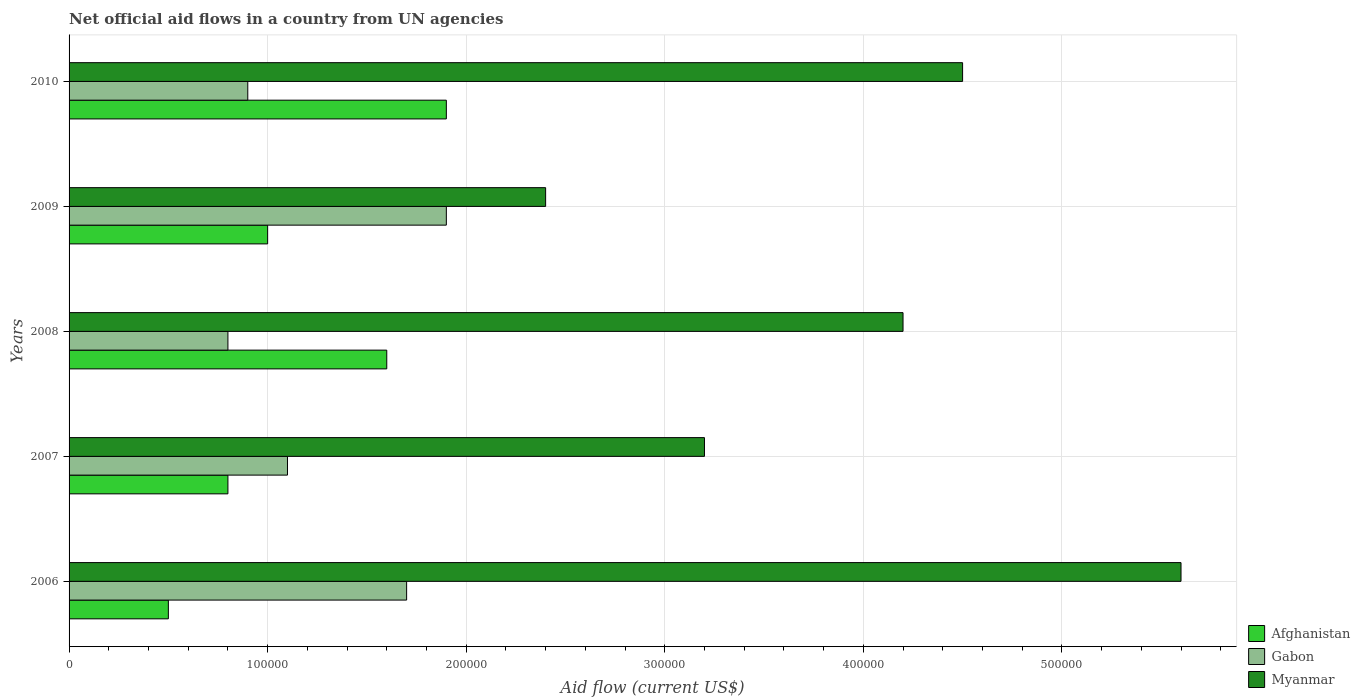How many groups of bars are there?
Offer a terse response. 5. Are the number of bars on each tick of the Y-axis equal?
Provide a short and direct response. Yes. In how many cases, is the number of bars for a given year not equal to the number of legend labels?
Your answer should be very brief. 0. What is the net official aid flow in Afghanistan in 2008?
Your answer should be compact. 1.60e+05. Across all years, what is the maximum net official aid flow in Myanmar?
Ensure brevity in your answer.  5.60e+05. Across all years, what is the minimum net official aid flow in Afghanistan?
Provide a succinct answer. 5.00e+04. In which year was the net official aid flow in Gabon maximum?
Give a very brief answer. 2009. What is the total net official aid flow in Gabon in the graph?
Provide a succinct answer. 6.40e+05. What is the difference between the net official aid flow in Gabon in 2006 and that in 2009?
Your answer should be compact. -2.00e+04. What is the difference between the net official aid flow in Myanmar in 2006 and the net official aid flow in Gabon in 2009?
Your answer should be very brief. 3.70e+05. What is the average net official aid flow in Gabon per year?
Your answer should be very brief. 1.28e+05. In the year 2006, what is the difference between the net official aid flow in Myanmar and net official aid flow in Gabon?
Your answer should be compact. 3.90e+05. What is the ratio of the net official aid flow in Gabon in 2006 to that in 2008?
Give a very brief answer. 2.12. Is the net official aid flow in Myanmar in 2009 less than that in 2010?
Your answer should be very brief. Yes. What is the difference between the highest and the second highest net official aid flow in Afghanistan?
Ensure brevity in your answer.  3.00e+04. What is the difference between the highest and the lowest net official aid flow in Gabon?
Ensure brevity in your answer.  1.10e+05. What does the 2nd bar from the top in 2009 represents?
Your answer should be compact. Gabon. What does the 3rd bar from the bottom in 2008 represents?
Give a very brief answer. Myanmar. Is it the case that in every year, the sum of the net official aid flow in Gabon and net official aid flow in Afghanistan is greater than the net official aid flow in Myanmar?
Offer a terse response. No. Are all the bars in the graph horizontal?
Make the answer very short. Yes. How many years are there in the graph?
Your answer should be very brief. 5. Does the graph contain grids?
Give a very brief answer. Yes. Where does the legend appear in the graph?
Make the answer very short. Bottom right. How many legend labels are there?
Your answer should be very brief. 3. What is the title of the graph?
Ensure brevity in your answer.  Net official aid flows in a country from UN agencies. What is the label or title of the X-axis?
Provide a short and direct response. Aid flow (current US$). What is the label or title of the Y-axis?
Your response must be concise. Years. What is the Aid flow (current US$) in Gabon in 2006?
Make the answer very short. 1.70e+05. What is the Aid flow (current US$) of Myanmar in 2006?
Offer a very short reply. 5.60e+05. What is the Aid flow (current US$) in Afghanistan in 2007?
Your answer should be very brief. 8.00e+04. What is the Aid flow (current US$) in Gabon in 2007?
Provide a short and direct response. 1.10e+05. What is the Aid flow (current US$) in Afghanistan in 2008?
Your response must be concise. 1.60e+05. What is the Aid flow (current US$) of Gabon in 2008?
Provide a short and direct response. 8.00e+04. What is the Aid flow (current US$) in Myanmar in 2008?
Keep it short and to the point. 4.20e+05. What is the Aid flow (current US$) in Gabon in 2009?
Your response must be concise. 1.90e+05. What is the Aid flow (current US$) of Myanmar in 2009?
Provide a succinct answer. 2.40e+05. What is the Aid flow (current US$) of Afghanistan in 2010?
Your response must be concise. 1.90e+05. What is the Aid flow (current US$) in Gabon in 2010?
Give a very brief answer. 9.00e+04. What is the Aid flow (current US$) of Myanmar in 2010?
Your answer should be compact. 4.50e+05. Across all years, what is the maximum Aid flow (current US$) in Afghanistan?
Your response must be concise. 1.90e+05. Across all years, what is the maximum Aid flow (current US$) of Gabon?
Your answer should be very brief. 1.90e+05. Across all years, what is the maximum Aid flow (current US$) of Myanmar?
Your response must be concise. 5.60e+05. Across all years, what is the minimum Aid flow (current US$) of Gabon?
Offer a very short reply. 8.00e+04. Across all years, what is the minimum Aid flow (current US$) of Myanmar?
Your answer should be very brief. 2.40e+05. What is the total Aid flow (current US$) in Afghanistan in the graph?
Offer a very short reply. 5.80e+05. What is the total Aid flow (current US$) of Gabon in the graph?
Make the answer very short. 6.40e+05. What is the total Aid flow (current US$) of Myanmar in the graph?
Offer a very short reply. 1.99e+06. What is the difference between the Aid flow (current US$) in Afghanistan in 2006 and that in 2007?
Your answer should be very brief. -3.00e+04. What is the difference between the Aid flow (current US$) of Afghanistan in 2006 and that in 2008?
Provide a short and direct response. -1.10e+05. What is the difference between the Aid flow (current US$) in Gabon in 2006 and that in 2009?
Ensure brevity in your answer.  -2.00e+04. What is the difference between the Aid flow (current US$) in Myanmar in 2006 and that in 2009?
Ensure brevity in your answer.  3.20e+05. What is the difference between the Aid flow (current US$) of Afghanistan in 2007 and that in 2008?
Give a very brief answer. -8.00e+04. What is the difference between the Aid flow (current US$) in Gabon in 2007 and that in 2008?
Give a very brief answer. 3.00e+04. What is the difference between the Aid flow (current US$) in Myanmar in 2007 and that in 2008?
Your answer should be compact. -1.00e+05. What is the difference between the Aid flow (current US$) of Afghanistan in 2007 and that in 2009?
Your answer should be very brief. -2.00e+04. What is the difference between the Aid flow (current US$) of Myanmar in 2007 and that in 2009?
Your response must be concise. 8.00e+04. What is the difference between the Aid flow (current US$) in Afghanistan in 2007 and that in 2010?
Make the answer very short. -1.10e+05. What is the difference between the Aid flow (current US$) in Gabon in 2007 and that in 2010?
Offer a very short reply. 2.00e+04. What is the difference between the Aid flow (current US$) in Myanmar in 2007 and that in 2010?
Give a very brief answer. -1.30e+05. What is the difference between the Aid flow (current US$) in Gabon in 2008 and that in 2009?
Provide a short and direct response. -1.10e+05. What is the difference between the Aid flow (current US$) of Gabon in 2008 and that in 2010?
Your answer should be very brief. -10000. What is the difference between the Aid flow (current US$) in Afghanistan in 2009 and that in 2010?
Your answer should be very brief. -9.00e+04. What is the difference between the Aid flow (current US$) of Gabon in 2009 and that in 2010?
Provide a succinct answer. 1.00e+05. What is the difference between the Aid flow (current US$) of Myanmar in 2009 and that in 2010?
Offer a very short reply. -2.10e+05. What is the difference between the Aid flow (current US$) in Afghanistan in 2006 and the Aid flow (current US$) in Myanmar in 2008?
Make the answer very short. -3.70e+05. What is the difference between the Aid flow (current US$) in Afghanistan in 2006 and the Aid flow (current US$) in Gabon in 2009?
Ensure brevity in your answer.  -1.40e+05. What is the difference between the Aid flow (current US$) in Gabon in 2006 and the Aid flow (current US$) in Myanmar in 2009?
Your response must be concise. -7.00e+04. What is the difference between the Aid flow (current US$) of Afghanistan in 2006 and the Aid flow (current US$) of Myanmar in 2010?
Make the answer very short. -4.00e+05. What is the difference between the Aid flow (current US$) in Gabon in 2006 and the Aid flow (current US$) in Myanmar in 2010?
Make the answer very short. -2.80e+05. What is the difference between the Aid flow (current US$) of Afghanistan in 2007 and the Aid flow (current US$) of Gabon in 2008?
Make the answer very short. 0. What is the difference between the Aid flow (current US$) of Gabon in 2007 and the Aid flow (current US$) of Myanmar in 2008?
Your answer should be compact. -3.10e+05. What is the difference between the Aid flow (current US$) of Afghanistan in 2007 and the Aid flow (current US$) of Myanmar in 2009?
Offer a very short reply. -1.60e+05. What is the difference between the Aid flow (current US$) in Afghanistan in 2007 and the Aid flow (current US$) in Gabon in 2010?
Offer a very short reply. -10000. What is the difference between the Aid flow (current US$) in Afghanistan in 2007 and the Aid flow (current US$) in Myanmar in 2010?
Offer a terse response. -3.70e+05. What is the difference between the Aid flow (current US$) in Afghanistan in 2008 and the Aid flow (current US$) in Gabon in 2009?
Offer a very short reply. -3.00e+04. What is the difference between the Aid flow (current US$) in Afghanistan in 2008 and the Aid flow (current US$) in Myanmar in 2009?
Give a very brief answer. -8.00e+04. What is the difference between the Aid flow (current US$) of Gabon in 2008 and the Aid flow (current US$) of Myanmar in 2009?
Your answer should be compact. -1.60e+05. What is the difference between the Aid flow (current US$) of Afghanistan in 2008 and the Aid flow (current US$) of Myanmar in 2010?
Your answer should be compact. -2.90e+05. What is the difference between the Aid flow (current US$) in Gabon in 2008 and the Aid flow (current US$) in Myanmar in 2010?
Offer a very short reply. -3.70e+05. What is the difference between the Aid flow (current US$) of Afghanistan in 2009 and the Aid flow (current US$) of Myanmar in 2010?
Provide a succinct answer. -3.50e+05. What is the difference between the Aid flow (current US$) of Gabon in 2009 and the Aid flow (current US$) of Myanmar in 2010?
Offer a terse response. -2.60e+05. What is the average Aid flow (current US$) of Afghanistan per year?
Your answer should be very brief. 1.16e+05. What is the average Aid flow (current US$) of Gabon per year?
Provide a succinct answer. 1.28e+05. What is the average Aid flow (current US$) in Myanmar per year?
Make the answer very short. 3.98e+05. In the year 2006, what is the difference between the Aid flow (current US$) in Afghanistan and Aid flow (current US$) in Gabon?
Give a very brief answer. -1.20e+05. In the year 2006, what is the difference between the Aid flow (current US$) of Afghanistan and Aid flow (current US$) of Myanmar?
Make the answer very short. -5.10e+05. In the year 2006, what is the difference between the Aid flow (current US$) in Gabon and Aid flow (current US$) in Myanmar?
Keep it short and to the point. -3.90e+05. In the year 2007, what is the difference between the Aid flow (current US$) in Afghanistan and Aid flow (current US$) in Gabon?
Offer a very short reply. -3.00e+04. In the year 2007, what is the difference between the Aid flow (current US$) in Afghanistan and Aid flow (current US$) in Myanmar?
Provide a succinct answer. -2.40e+05. In the year 2007, what is the difference between the Aid flow (current US$) in Gabon and Aid flow (current US$) in Myanmar?
Make the answer very short. -2.10e+05. In the year 2008, what is the difference between the Aid flow (current US$) of Gabon and Aid flow (current US$) of Myanmar?
Keep it short and to the point. -3.40e+05. In the year 2009, what is the difference between the Aid flow (current US$) of Afghanistan and Aid flow (current US$) of Gabon?
Your answer should be compact. -9.00e+04. In the year 2009, what is the difference between the Aid flow (current US$) in Afghanistan and Aid flow (current US$) in Myanmar?
Your response must be concise. -1.40e+05. In the year 2010, what is the difference between the Aid flow (current US$) of Afghanistan and Aid flow (current US$) of Myanmar?
Give a very brief answer. -2.60e+05. In the year 2010, what is the difference between the Aid flow (current US$) in Gabon and Aid flow (current US$) in Myanmar?
Offer a very short reply. -3.60e+05. What is the ratio of the Aid flow (current US$) in Gabon in 2006 to that in 2007?
Your response must be concise. 1.55. What is the ratio of the Aid flow (current US$) of Myanmar in 2006 to that in 2007?
Give a very brief answer. 1.75. What is the ratio of the Aid flow (current US$) of Afghanistan in 2006 to that in 2008?
Keep it short and to the point. 0.31. What is the ratio of the Aid flow (current US$) in Gabon in 2006 to that in 2008?
Provide a short and direct response. 2.12. What is the ratio of the Aid flow (current US$) of Myanmar in 2006 to that in 2008?
Provide a short and direct response. 1.33. What is the ratio of the Aid flow (current US$) of Afghanistan in 2006 to that in 2009?
Make the answer very short. 0.5. What is the ratio of the Aid flow (current US$) of Gabon in 2006 to that in 2009?
Make the answer very short. 0.89. What is the ratio of the Aid flow (current US$) of Myanmar in 2006 to that in 2009?
Your answer should be compact. 2.33. What is the ratio of the Aid flow (current US$) in Afghanistan in 2006 to that in 2010?
Offer a terse response. 0.26. What is the ratio of the Aid flow (current US$) of Gabon in 2006 to that in 2010?
Keep it short and to the point. 1.89. What is the ratio of the Aid flow (current US$) in Myanmar in 2006 to that in 2010?
Make the answer very short. 1.24. What is the ratio of the Aid flow (current US$) in Afghanistan in 2007 to that in 2008?
Offer a very short reply. 0.5. What is the ratio of the Aid flow (current US$) in Gabon in 2007 to that in 2008?
Keep it short and to the point. 1.38. What is the ratio of the Aid flow (current US$) in Myanmar in 2007 to that in 2008?
Offer a very short reply. 0.76. What is the ratio of the Aid flow (current US$) in Gabon in 2007 to that in 2009?
Keep it short and to the point. 0.58. What is the ratio of the Aid flow (current US$) in Afghanistan in 2007 to that in 2010?
Your answer should be very brief. 0.42. What is the ratio of the Aid flow (current US$) in Gabon in 2007 to that in 2010?
Provide a short and direct response. 1.22. What is the ratio of the Aid flow (current US$) of Myanmar in 2007 to that in 2010?
Provide a succinct answer. 0.71. What is the ratio of the Aid flow (current US$) of Afghanistan in 2008 to that in 2009?
Ensure brevity in your answer.  1.6. What is the ratio of the Aid flow (current US$) in Gabon in 2008 to that in 2009?
Offer a terse response. 0.42. What is the ratio of the Aid flow (current US$) of Afghanistan in 2008 to that in 2010?
Provide a short and direct response. 0.84. What is the ratio of the Aid flow (current US$) in Gabon in 2008 to that in 2010?
Provide a succinct answer. 0.89. What is the ratio of the Aid flow (current US$) of Myanmar in 2008 to that in 2010?
Your response must be concise. 0.93. What is the ratio of the Aid flow (current US$) in Afghanistan in 2009 to that in 2010?
Ensure brevity in your answer.  0.53. What is the ratio of the Aid flow (current US$) in Gabon in 2009 to that in 2010?
Provide a succinct answer. 2.11. What is the ratio of the Aid flow (current US$) in Myanmar in 2009 to that in 2010?
Your answer should be compact. 0.53. What is the difference between the highest and the second highest Aid flow (current US$) in Afghanistan?
Offer a very short reply. 3.00e+04. What is the difference between the highest and the second highest Aid flow (current US$) in Gabon?
Offer a very short reply. 2.00e+04. What is the difference between the highest and the second highest Aid flow (current US$) of Myanmar?
Provide a short and direct response. 1.10e+05. What is the difference between the highest and the lowest Aid flow (current US$) of Afghanistan?
Keep it short and to the point. 1.40e+05. What is the difference between the highest and the lowest Aid flow (current US$) of Myanmar?
Offer a terse response. 3.20e+05. 